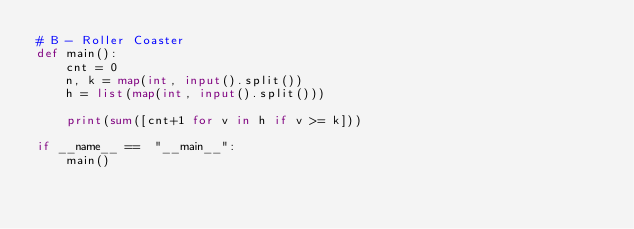Convert code to text. <code><loc_0><loc_0><loc_500><loc_500><_Python_># B - Roller Coaster
def main():
    cnt = 0
    n, k = map(int, input().split())
    h = list(map(int, input().split()))

    print(sum([cnt+1 for v in h if v >= k]))

if __name__ ==  "__main__":
    main()</code> 